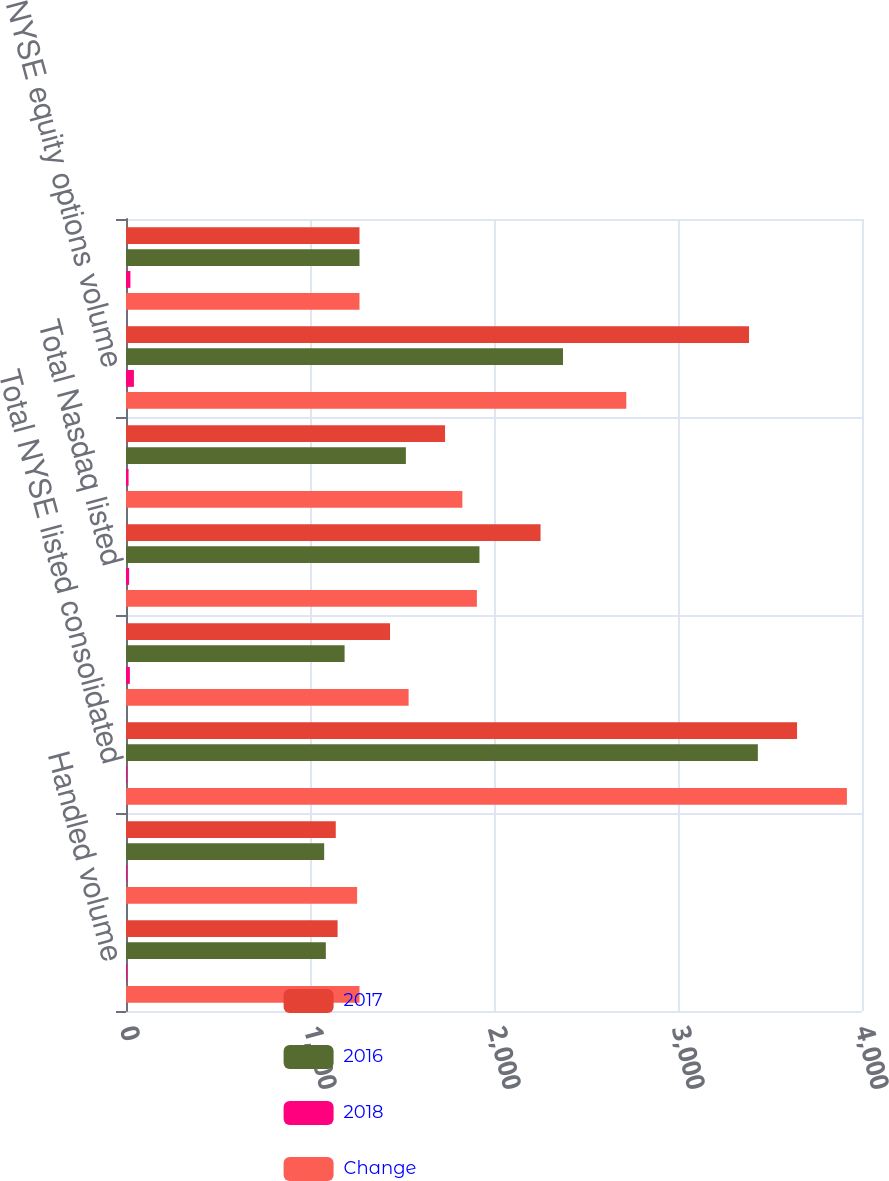<chart> <loc_0><loc_0><loc_500><loc_500><stacked_bar_chart><ecel><fcel>Handled volume<fcel>Matched volume<fcel>Total NYSE listed consolidated<fcel>Total NYSE T Arca NYSE<fcel>Total Nasdaq listed<fcel>Total cash handled volume<fcel>NYSE equity options volume<fcel>Total equity options volume T<nl><fcel>2017<fcel>1150<fcel>1140<fcel>3647<fcel>1435<fcel>2253<fcel>1734<fcel>3386<fcel>1269<nl><fcel>2016<fcel>1086<fcel>1077<fcel>3434<fcel>1188<fcel>1921<fcel>1521<fcel>2375<fcel>1269<nl><fcel>2018<fcel>6<fcel>6<fcel>6<fcel>21<fcel>17<fcel>14<fcel>43<fcel>24<nl><fcel>Change<fcel>1269<fcel>1256<fcel>3918<fcel>1536<fcel>1907<fcel>1828<fcel>2719<fcel>1269<nl></chart> 